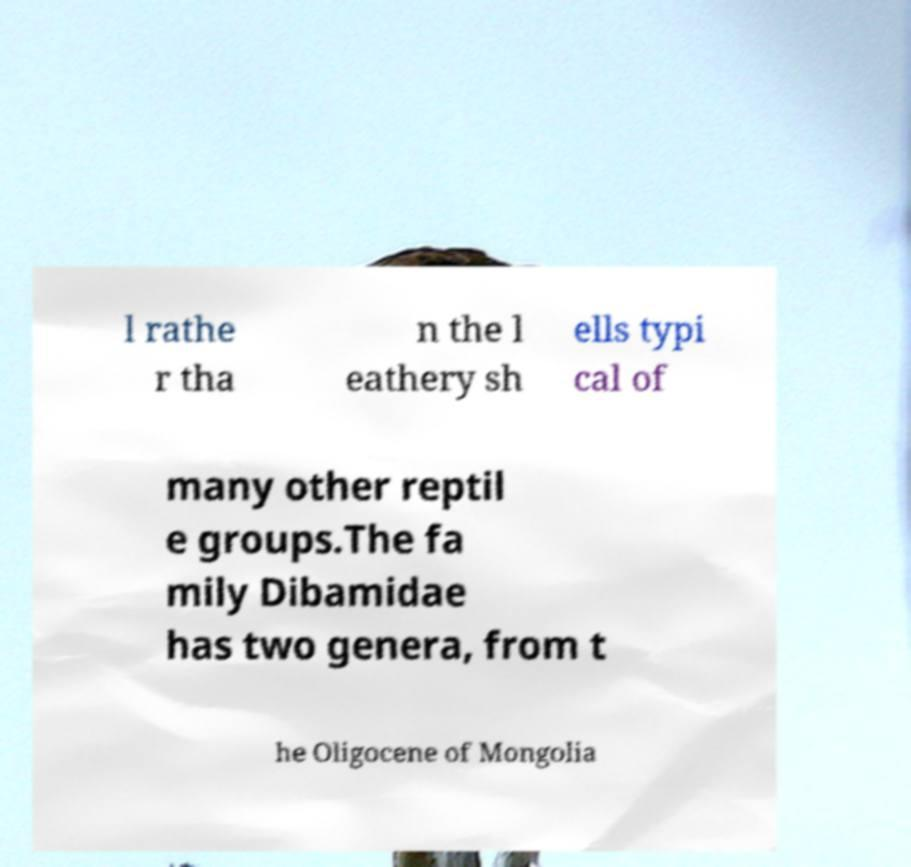What messages or text are displayed in this image? I need them in a readable, typed format. l rathe r tha n the l eathery sh ells typi cal of many other reptil e groups.The fa mily Dibamidae has two genera, from t he Oligocene of Mongolia 